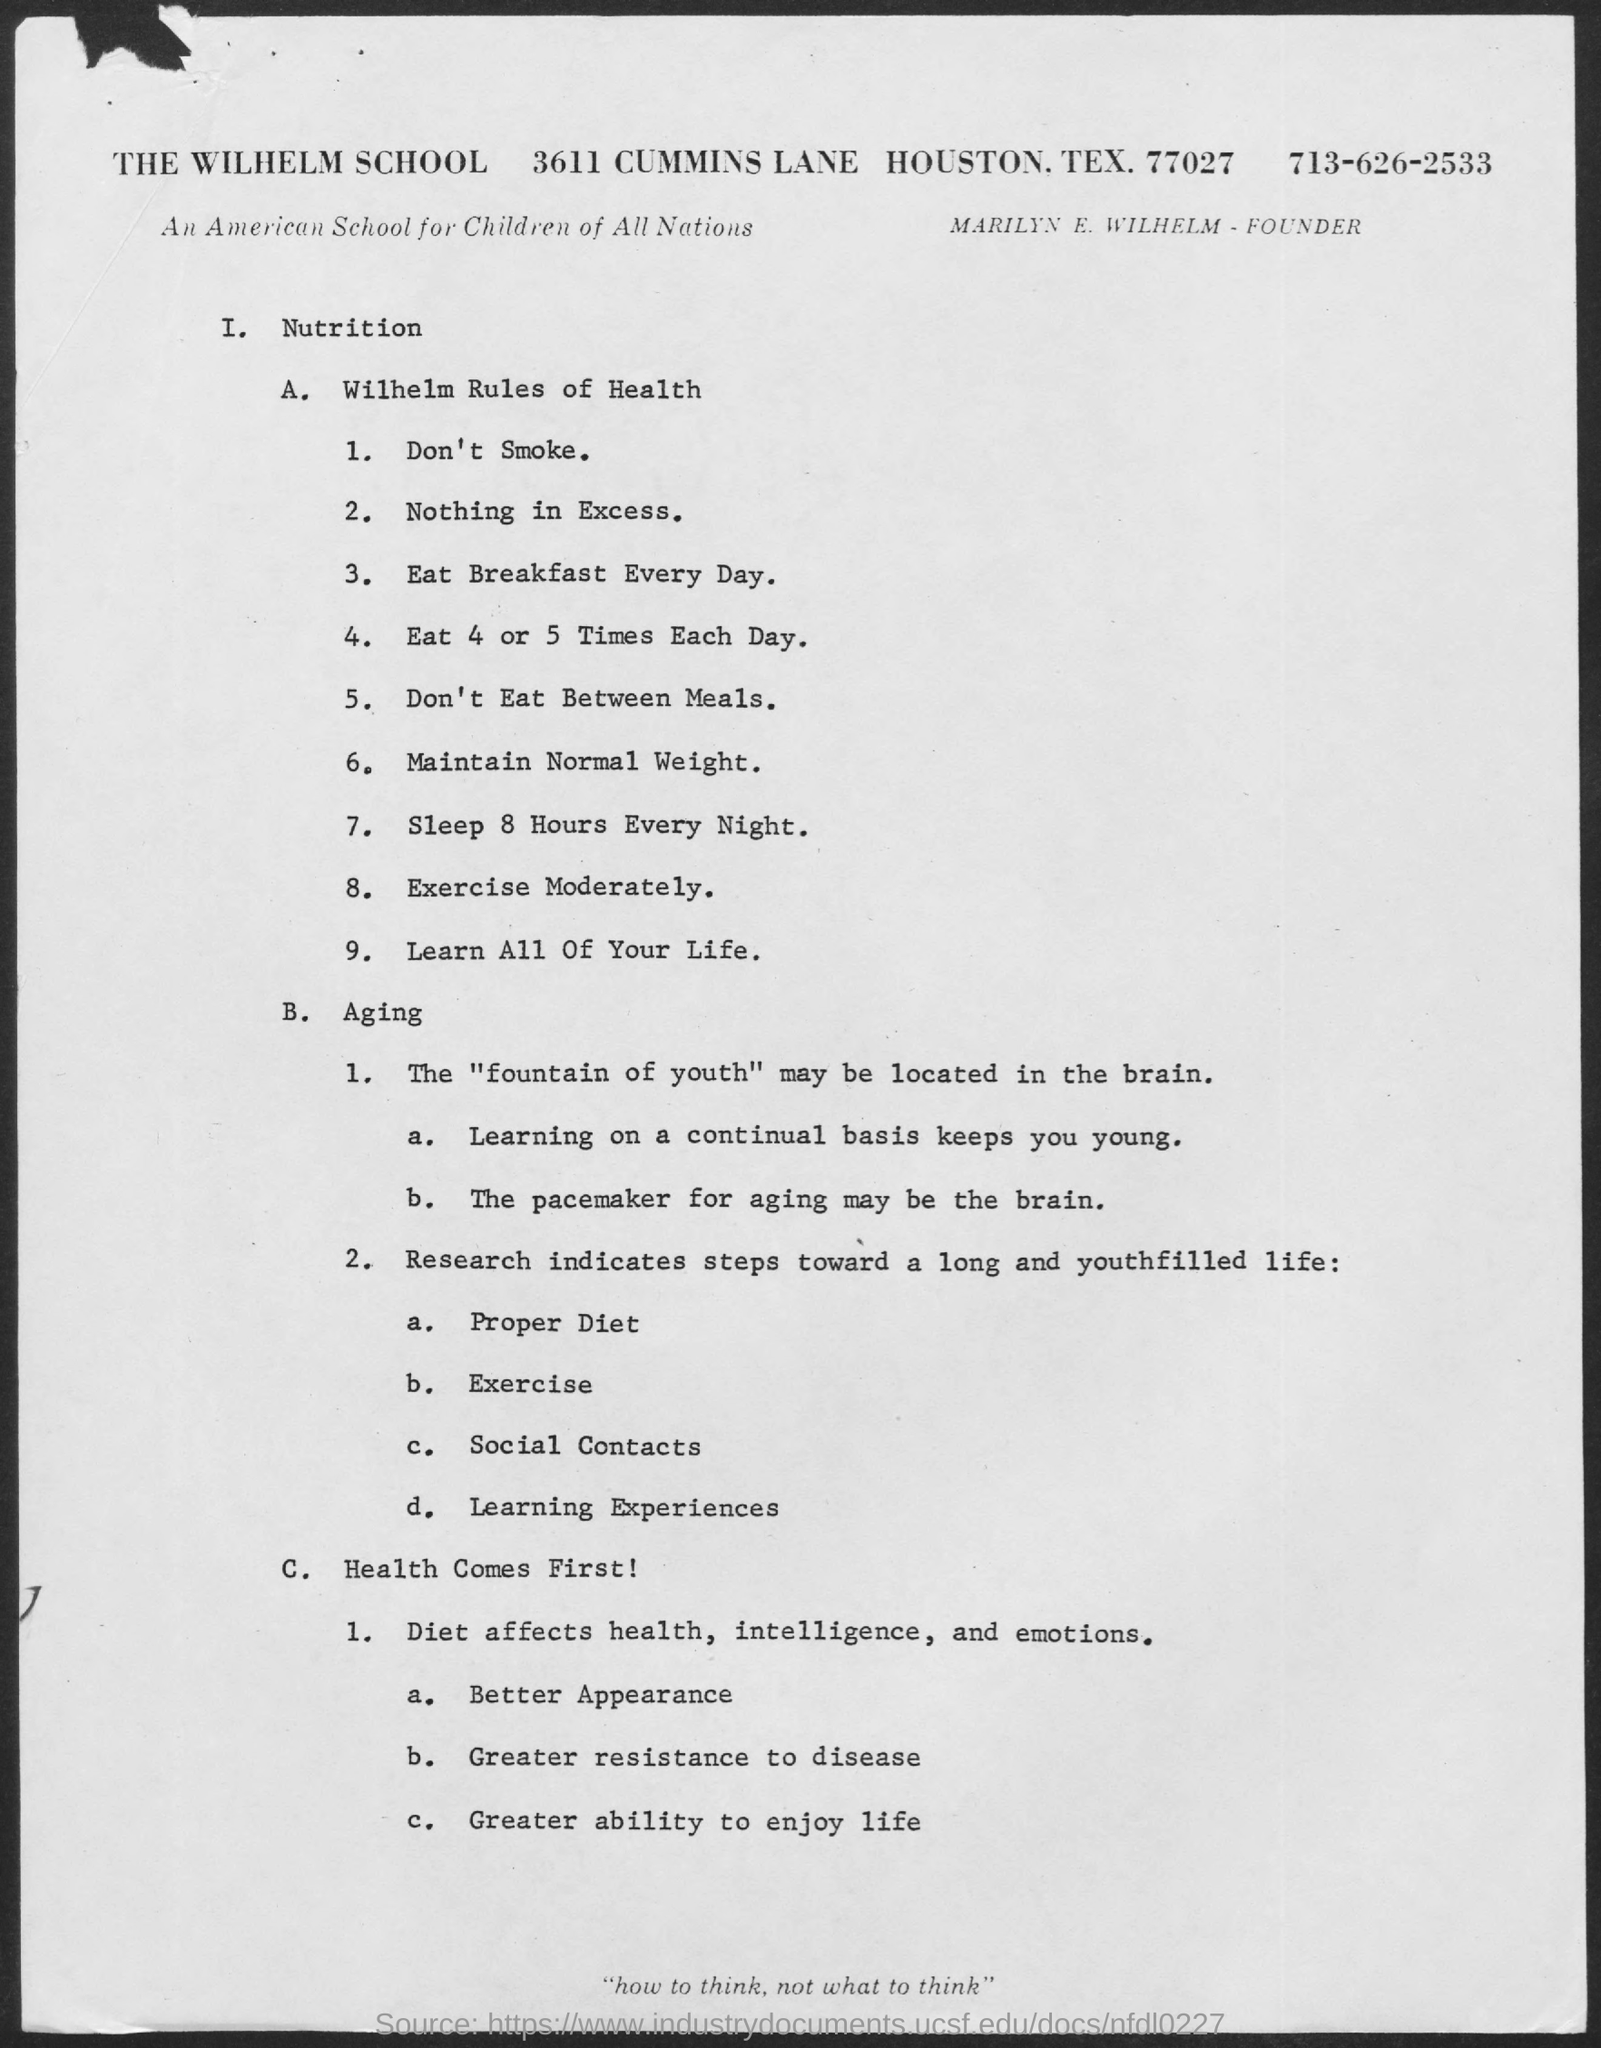Identify some key points in this picture. The name of the school is Wilhelm School. The phone number mentioned in the document is 713-626-2533. Marilyn E. Wilhelm is the founder of the company. 